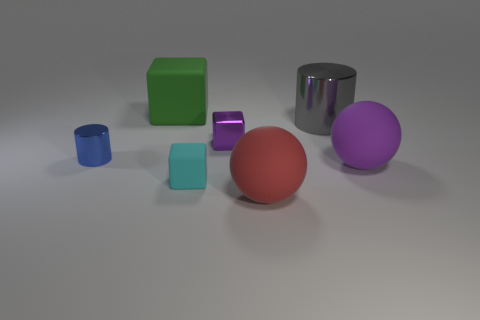Does the tiny cylinder have the same material as the ball on the right side of the red rubber ball?
Keep it short and to the point. No. There is a red object that is the same material as the big green cube; what size is it?
Keep it short and to the point. Large. Are there any purple shiny things of the same shape as the small cyan thing?
Offer a very short reply. Yes. What number of things are cylinders that are to the right of the big red rubber sphere or green things?
Keep it short and to the point. 2. What size is the object that is the same color as the small metallic block?
Ensure brevity in your answer.  Large. There is a large object that is to the right of the gray metallic cylinder; does it have the same color as the tiny block that is in front of the small blue metallic object?
Provide a short and direct response. No. What size is the purple shiny block?
Give a very brief answer. Small. What number of big things are either red rubber objects or green rubber objects?
Provide a short and direct response. 2. There is a cylinder that is the same size as the cyan thing; what color is it?
Ensure brevity in your answer.  Blue. How many other objects are there of the same shape as the tiny blue metallic object?
Make the answer very short. 1. 